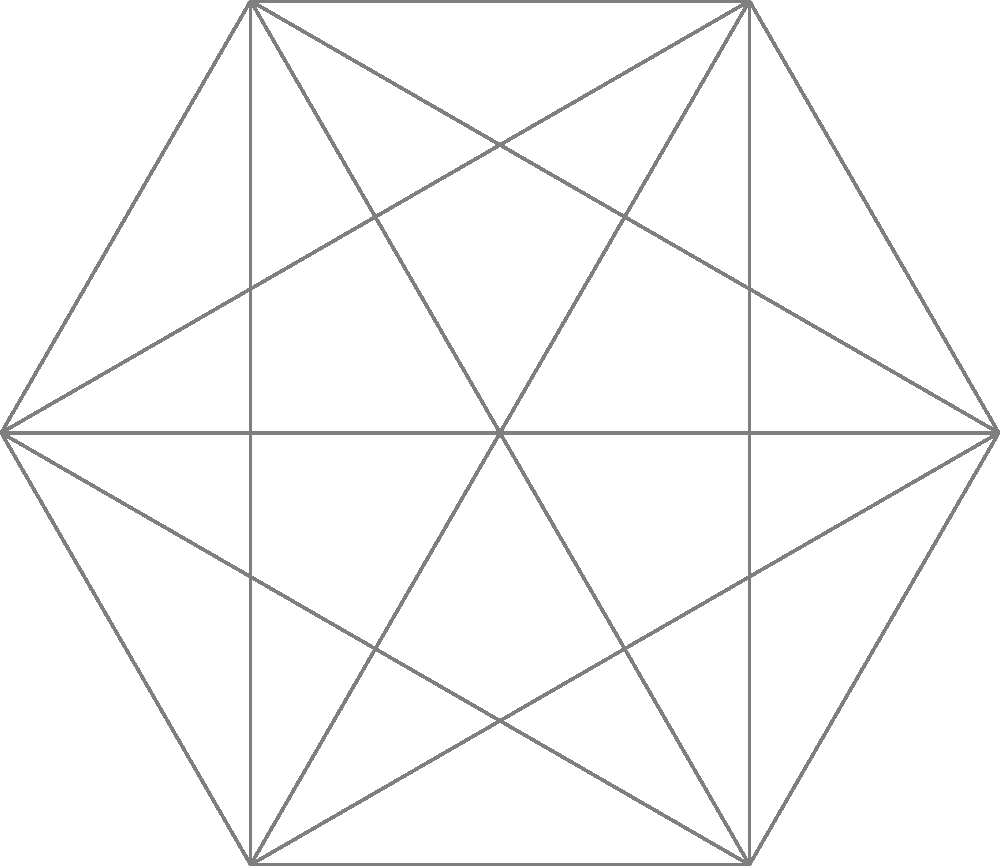In the given network of interconnected AI systems, personal data flows through the network in a specific pattern. If the data transfer starts at AI1 and follows the colored arrows, which AI system will be the last to receive the data before it completes a full cycle? To solve this problem, we need to follow the data flow through the network:

1. The data starts at AI1 (center node).
2. It flows to AI2 along the blue arrow.
3. From AI2, it moves to AI3 via the red arrow.
4. The green arrow takes the data from AI3 to AI4.
5. The orange arrow directs the flow from AI4 to AI5.
6. The purple arrow shows the data moving from AI5 to AI6.
7. The brown arrow indicates the transfer from AI6 to AI7.
8. Finally, the gray arrow would complete the cycle by returning to AI1.

Therefore, the last AI system to receive the data before completing a full cycle is AI7.

This spatial reasoning task demonstrates how personal data can be distributed and transferred across interconnected AI networks, which is relevant to the study of AI's impact on privacy rights. Understanding these data flow patterns is crucial for identifying potential privacy vulnerabilities and developing appropriate safeguards.
Answer: AI7 